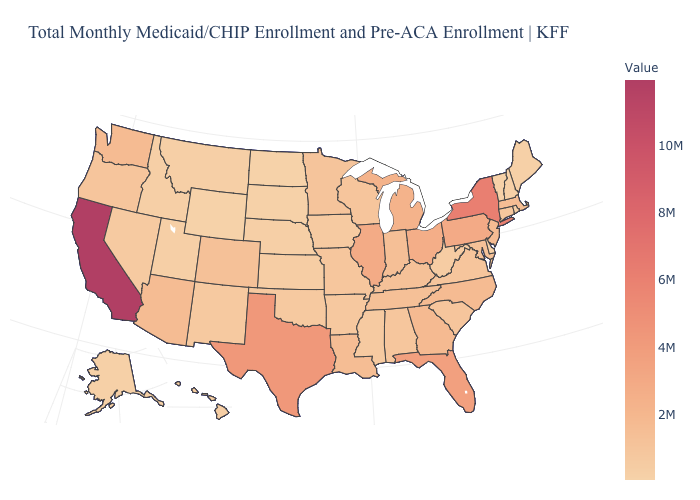Is the legend a continuous bar?
Give a very brief answer. Yes. Which states have the highest value in the USA?
Quick response, please. California. 